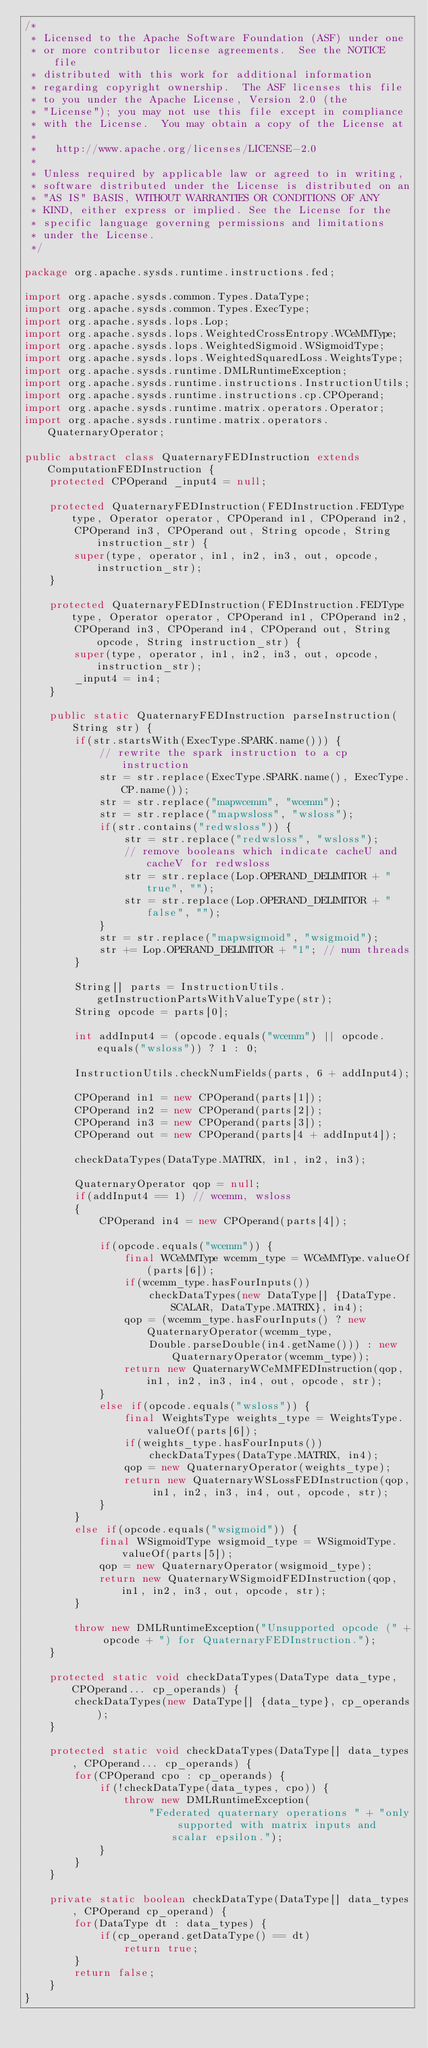<code> <loc_0><loc_0><loc_500><loc_500><_Java_>/*
 * Licensed to the Apache Software Foundation (ASF) under one
 * or more contributor license agreements.  See the NOTICE file
 * distributed with this work for additional information
 * regarding copyright ownership.  The ASF licenses this file
 * to you under the Apache License, Version 2.0 (the
 * "License"); you may not use this file except in compliance
 * with the License.  You may obtain a copy of the License at
 *
 *	 http://www.apache.org/licenses/LICENSE-2.0
 *
 * Unless required by applicable law or agreed to in writing,
 * software distributed under the License is distributed on an
 * "AS IS" BASIS, WITHOUT WARRANTIES OR CONDITIONS OF ANY
 * KIND, either express or implied.	See the License for the
 * specific language governing permissions and limitations
 * under the License.
 */

package org.apache.sysds.runtime.instructions.fed;

import org.apache.sysds.common.Types.DataType;
import org.apache.sysds.common.Types.ExecType;
import org.apache.sysds.lops.Lop;
import org.apache.sysds.lops.WeightedCrossEntropy.WCeMMType;
import org.apache.sysds.lops.WeightedSigmoid.WSigmoidType;
import org.apache.sysds.lops.WeightedSquaredLoss.WeightsType;
import org.apache.sysds.runtime.DMLRuntimeException;
import org.apache.sysds.runtime.instructions.InstructionUtils;
import org.apache.sysds.runtime.instructions.cp.CPOperand;
import org.apache.sysds.runtime.matrix.operators.Operator;
import org.apache.sysds.runtime.matrix.operators.QuaternaryOperator;

public abstract class QuaternaryFEDInstruction extends ComputationFEDInstruction {
	protected CPOperand _input4 = null;

	protected QuaternaryFEDInstruction(FEDInstruction.FEDType type, Operator operator, CPOperand in1, CPOperand in2,
		CPOperand in3, CPOperand out, String opcode, String instruction_str) {
		super(type, operator, in1, in2, in3, out, opcode, instruction_str);
	}

	protected QuaternaryFEDInstruction(FEDInstruction.FEDType type, Operator operator, CPOperand in1, CPOperand in2,
		CPOperand in3, CPOperand in4, CPOperand out, String opcode, String instruction_str) {
		super(type, operator, in1, in2, in3, out, opcode, instruction_str);
		_input4 = in4;
	}

	public static QuaternaryFEDInstruction parseInstruction(String str) {
		if(str.startsWith(ExecType.SPARK.name())) {
			// rewrite the spark instruction to a cp instruction
			str = str.replace(ExecType.SPARK.name(), ExecType.CP.name());
			str = str.replace("mapwcemm", "wcemm");
			str = str.replace("mapwsloss", "wsloss");
			if(str.contains("redwsloss")) {
				str = str.replace("redwsloss", "wsloss");
				// remove booleans which indicate cacheU and cacheV for redwsloss
				str = str.replace(Lop.OPERAND_DELIMITOR + "true", "");
				str = str.replace(Lop.OPERAND_DELIMITOR + "false", "");
			}
			str = str.replace("mapwsigmoid", "wsigmoid");
			str += Lop.OPERAND_DELIMITOR + "1"; // num threads
		}

		String[] parts = InstructionUtils.getInstructionPartsWithValueType(str);
		String opcode = parts[0];

		int addInput4 = (opcode.equals("wcemm") || opcode.equals("wsloss")) ? 1 : 0;

		InstructionUtils.checkNumFields(parts, 6 + addInput4);

		CPOperand in1 = new CPOperand(parts[1]);
		CPOperand in2 = new CPOperand(parts[2]);
		CPOperand in3 = new CPOperand(parts[3]);
		CPOperand out = new CPOperand(parts[4 + addInput4]);

		checkDataTypes(DataType.MATRIX, in1, in2, in3);

		QuaternaryOperator qop = null;
		if(addInput4 == 1) // wcemm, wsloss
		{
			CPOperand in4 = new CPOperand(parts[4]);

			if(opcode.equals("wcemm")) {
				final WCeMMType wcemm_type = WCeMMType.valueOf(parts[6]);
				if(wcemm_type.hasFourInputs())
					checkDataTypes(new DataType[] {DataType.SCALAR, DataType.MATRIX}, in4);
				qop = (wcemm_type.hasFourInputs() ? new QuaternaryOperator(wcemm_type,
					Double.parseDouble(in4.getName())) : new QuaternaryOperator(wcemm_type));
				return new QuaternaryWCeMMFEDInstruction(qop, in1, in2, in3, in4, out, opcode, str);
			}
			else if(opcode.equals("wsloss")) {
				final WeightsType weights_type = WeightsType.valueOf(parts[6]);
				if(weights_type.hasFourInputs())
					checkDataTypes(DataType.MATRIX, in4);
				qop = new QuaternaryOperator(weights_type);
				return new QuaternaryWSLossFEDInstruction(qop, in1, in2, in3, in4, out, opcode, str);
			}
		}
		else if(opcode.equals("wsigmoid")) {
			final WSigmoidType wsigmoid_type = WSigmoidType.valueOf(parts[5]);
			qop = new QuaternaryOperator(wsigmoid_type);
			return new QuaternaryWSigmoidFEDInstruction(qop, in1, in2, in3, out, opcode, str);
		}

		throw new DMLRuntimeException("Unsupported opcode (" + opcode + ") for QuaternaryFEDInstruction.");
	}

	protected static void checkDataTypes(DataType data_type, CPOperand... cp_operands) {
		checkDataTypes(new DataType[] {data_type}, cp_operands);
	}

	protected static void checkDataTypes(DataType[] data_types, CPOperand... cp_operands) {
		for(CPOperand cpo : cp_operands) {
			if(!checkDataType(data_types, cpo)) {
				throw new DMLRuntimeException(
					"Federated quaternary operations " + "only supported with matrix inputs and scalar epsilon.");
			}
		}
	}

	private static boolean checkDataType(DataType[] data_types, CPOperand cp_operand) {
		for(DataType dt : data_types) {
			if(cp_operand.getDataType() == dt)
				return true;
		}
		return false;
	}
}
</code> 